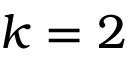Convert formula to latex. <formula><loc_0><loc_0><loc_500><loc_500>k = 2</formula> 